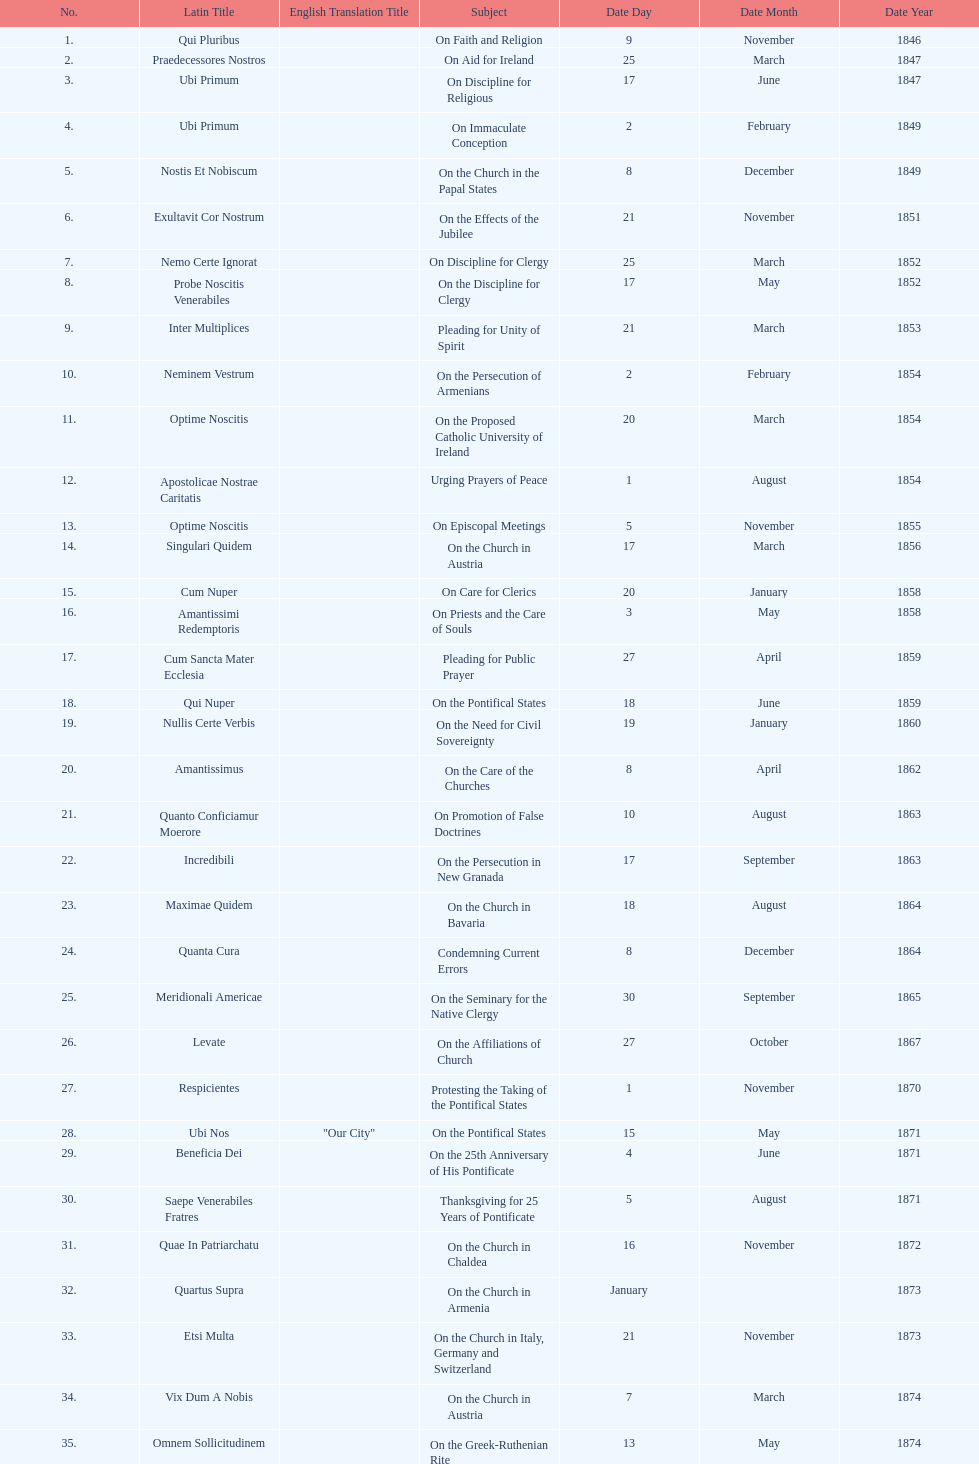How many subjects are there? 38. 